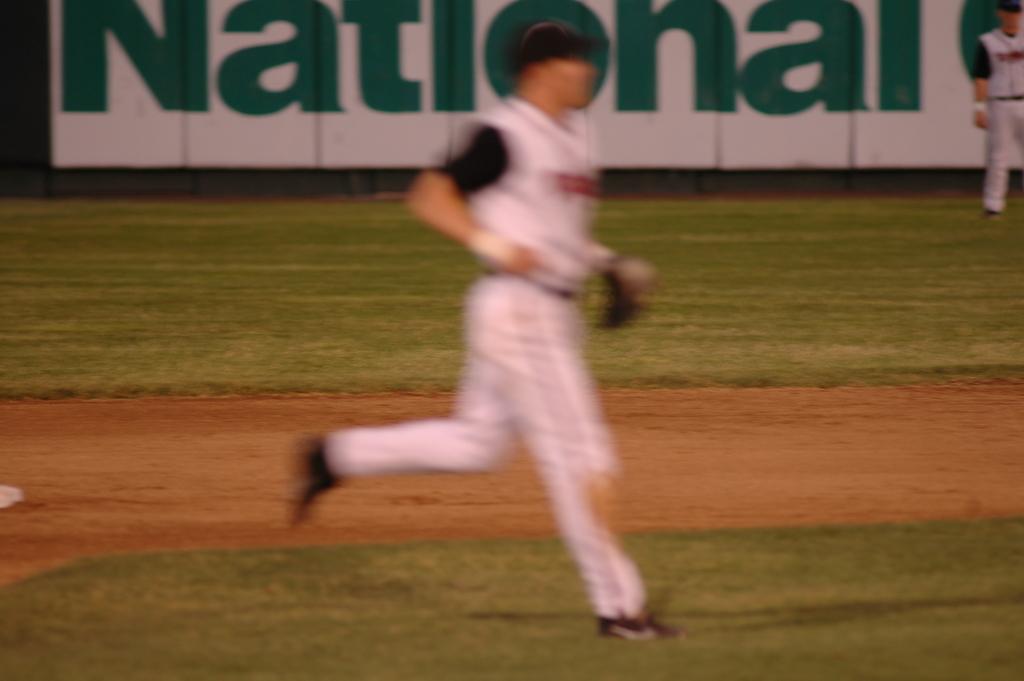What does the sign say in the very back?
Offer a very short reply. National. 